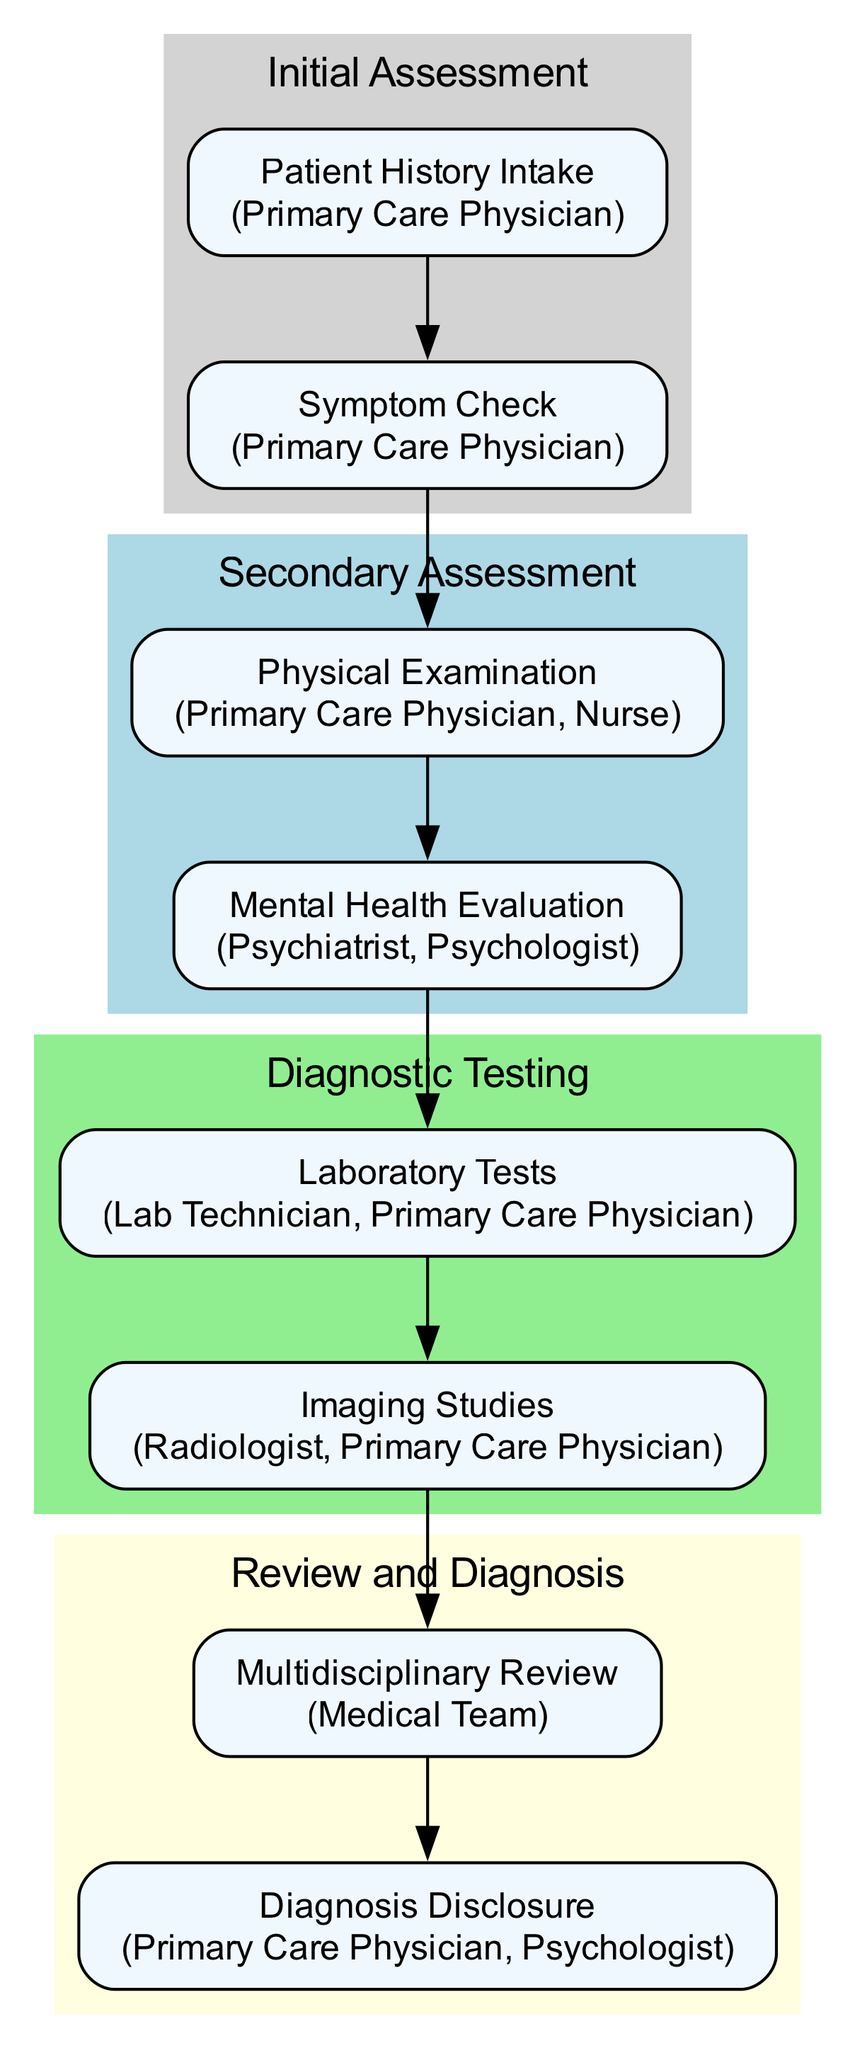What is the first step in the Initial Assessment? The first step is "Patient History Intake". According to the diagram, this is the first action outlined in the Initial Assessment stage.
Answer: Patient History Intake Who is responsible for the Mental Health Evaluation? The responsible parties for the Mental Health Evaluation are the Psychiatrist and Psychologist, as specified under the Secondary Assessment section of the diagram.
Answer: Psychiatrist, Psychologist How many main stages are there in the diagnostic pathway? There are four main stages: Initial Assessment, Secondary Assessment, Diagnostic Testing, and Review and Diagnosis. This can be counted from the distinct clusters in the diagram.
Answer: Four What does Step 6 involve? Step 6 involves "Imaging Studies". Referring to the Diagnostic Testing section, this is the specific action listed at this point in the pathway.
Answer: Imaging Studies What edge connects the Symptom Check to Physical Examination? The edge that connects the Symptom Check to Physical Examination represents the progression from identifying symptoms to conducting a physical examination, which is shown by the directed arrow in the diagram linking these two steps.
Answer: Yes What is the outcome of the Multidisciplinary Review? The outcome of the Multidisciplinary Review is to discuss findings and consider differential diagnoses, as indicated in Step 7 of the Review and Diagnosis section.
Answer: Discuss findings and consider differential diagnoses How many responsible parties are listed for the Physical Examination? There are two responsible parties listed: Primary Care Physician and Nurse. This information can be found in the description of Step 3 under the Secondary Assessment section.
Answer: Two What is one symptom to identify during the Symptom Check? One symptom to identify is chronic pain. It is specifically mentioned in the list of actions for Step 2.
Answer: Chronic pain What should happen after Imaging Studies? After Imaging Studies, a Multidisciplinary Review should occur. This sequence of steps is reflected in the directional connection indicated in the diagram.
Answer: Multidisciplinary Review 